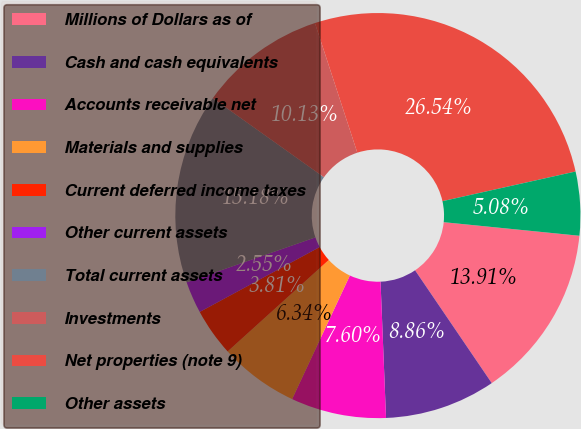Convert chart to OTSL. <chart><loc_0><loc_0><loc_500><loc_500><pie_chart><fcel>Millions of Dollars as of<fcel>Cash and cash equivalents<fcel>Accounts receivable net<fcel>Materials and supplies<fcel>Current deferred income taxes<fcel>Other current assets<fcel>Total current assets<fcel>Investments<fcel>Net properties (note 9)<fcel>Other assets<nl><fcel>13.91%<fcel>8.86%<fcel>7.6%<fcel>6.34%<fcel>3.81%<fcel>2.55%<fcel>15.18%<fcel>10.13%<fcel>26.54%<fcel>5.08%<nl></chart> 